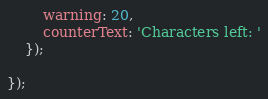<code> <loc_0><loc_0><loc_500><loc_500><_JavaScript_>        warning: 20,
        counterText: 'Characters left: '
    });

});
</code> 